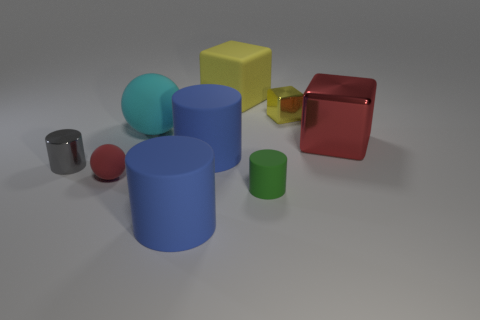What materials do the objects in the image appear to be made of? The objects in the image have a range of appearances suggesting different materials. The cylinders and cubes exhibit matte, shiny, and slightly reflective surfaces, which could be indicative of plastic, metal, and rubber materials respectively. 